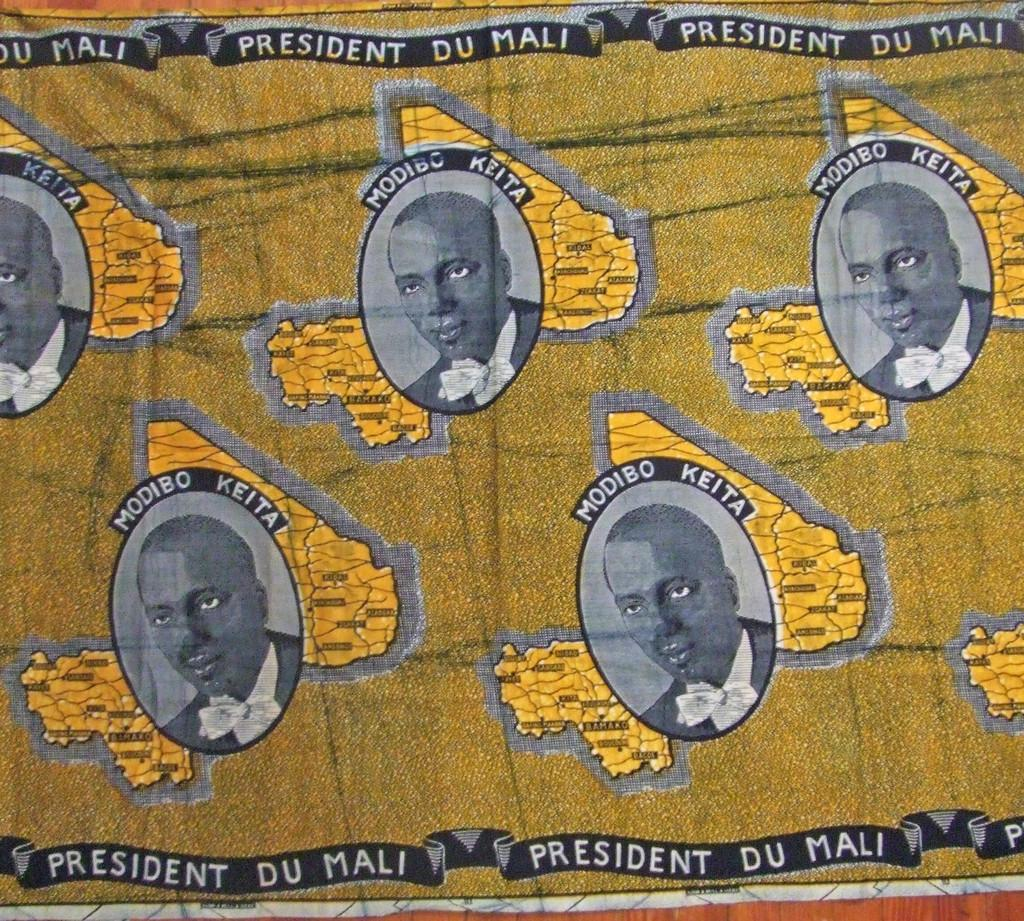What is the main object in the image? There is a banner in the image. What is depicted on the banner? The banner contains images of a president. What additional information about the president is provided on the banner? The president's name is mentioned on the banner. What type of honey is being used to write the president's name on the banner? There is no honey present in the image, and the president's name is not written with any substance. 